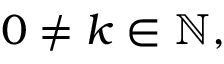Convert formula to latex. <formula><loc_0><loc_0><loc_500><loc_500>0 \neq k \in \mathbb { N } ,</formula> 